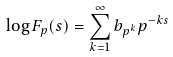<formula> <loc_0><loc_0><loc_500><loc_500>\log F _ { p } ( s ) = \sum _ { k = 1 } ^ { \infty } b _ { p ^ { k } } p ^ { - k s }</formula> 